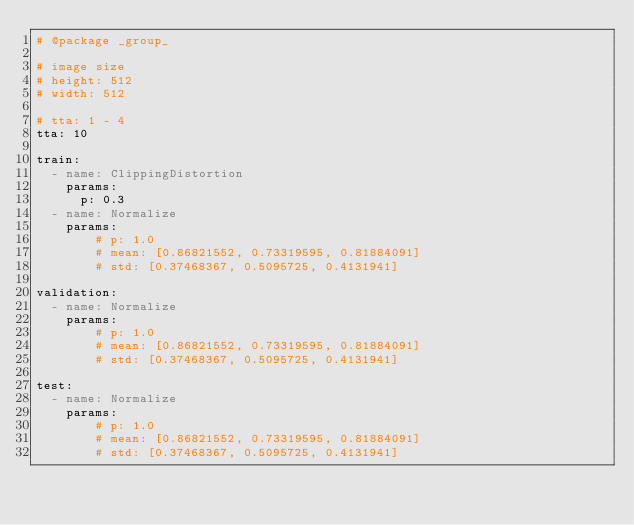Convert code to text. <code><loc_0><loc_0><loc_500><loc_500><_YAML_># @package _group_

# image size
# height: 512
# width: 512

# tta: 1 - 4
tta: 10

train:
  - name: ClippingDistortion
    params:
      p: 0.3
  - name: Normalize
    params:
        # p: 1.0
        # mean: [0.86821552, 0.73319595, 0.81884091]
        # std: [0.37468367, 0.5095725, 0.4131941]

validation:
  - name: Normalize
    params:
        # p: 1.0
        # mean: [0.86821552, 0.73319595, 0.81884091]
        # std: [0.37468367, 0.5095725, 0.4131941]

test:
  - name: Normalize
    params:
        # p: 1.0
        # mean: [0.86821552, 0.73319595, 0.81884091]
        # std: [0.37468367, 0.5095725, 0.4131941]
</code> 